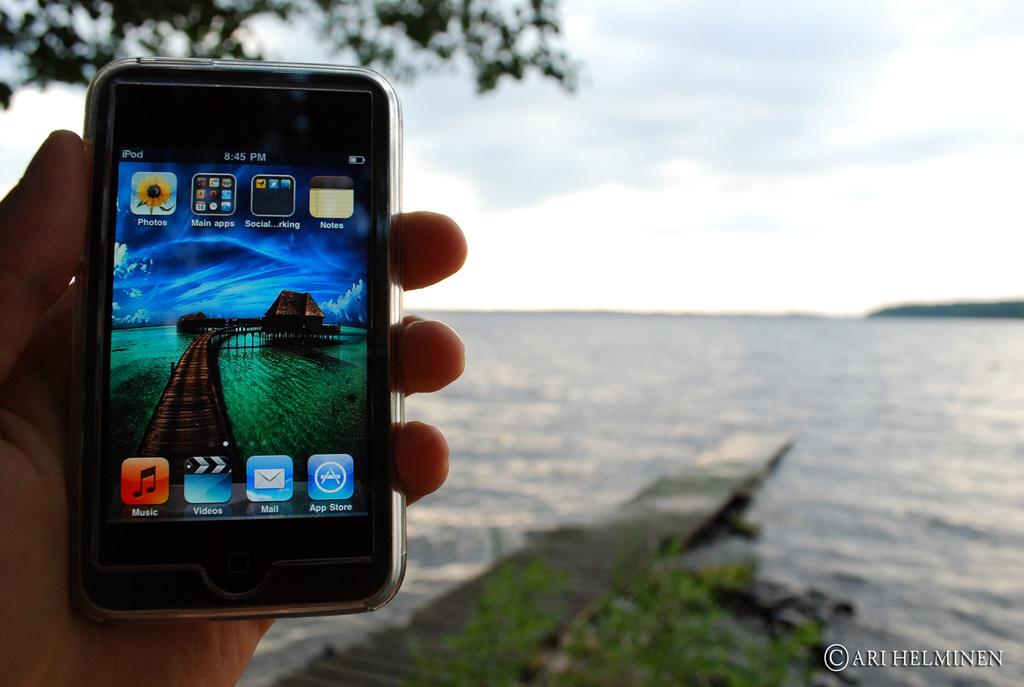Provide a one-sentence caption for the provided image. A hand holding a cellphone with one of the icons saying Music. 